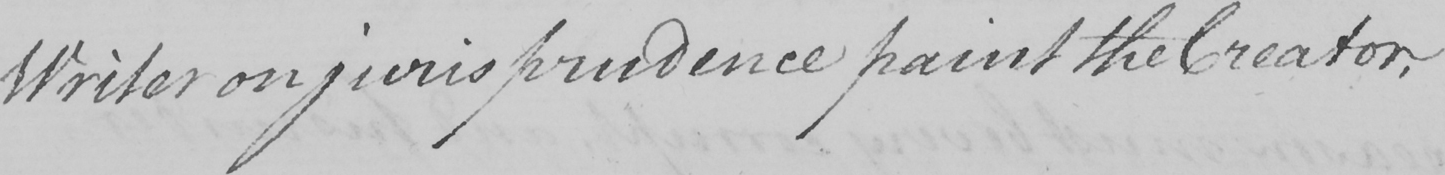Please transcribe the handwritten text in this image. Writer on jurisprudence paint the Creator , 